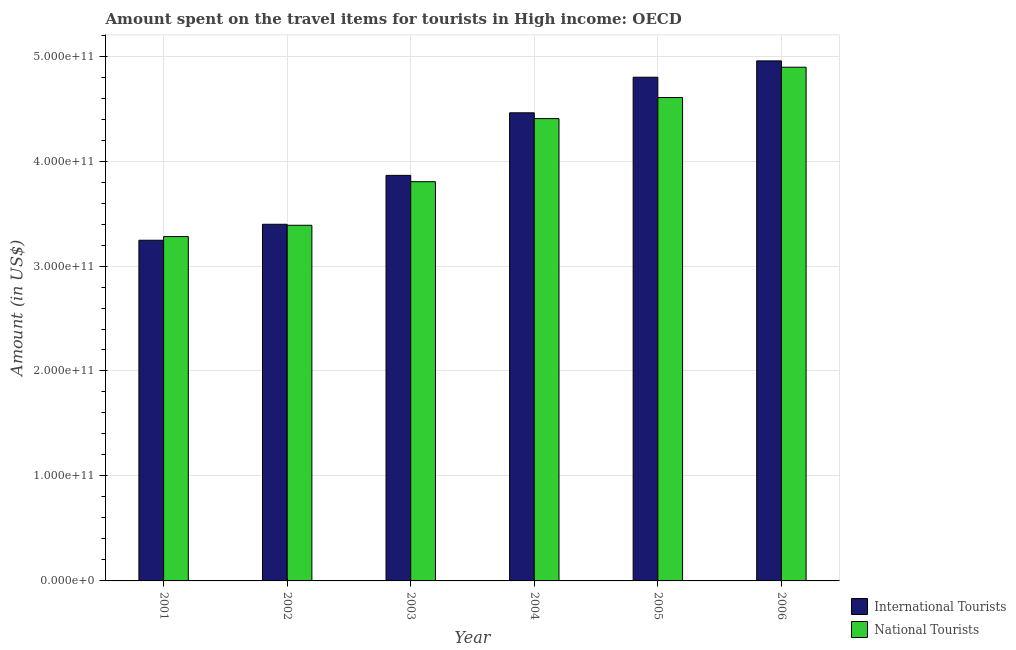Are the number of bars on each tick of the X-axis equal?
Give a very brief answer. Yes. What is the amount spent on travel items of national tourists in 2003?
Your response must be concise. 3.80e+11. Across all years, what is the maximum amount spent on travel items of national tourists?
Ensure brevity in your answer.  4.89e+11. Across all years, what is the minimum amount spent on travel items of national tourists?
Make the answer very short. 3.28e+11. In which year was the amount spent on travel items of national tourists minimum?
Your answer should be very brief. 2001. What is the total amount spent on travel items of national tourists in the graph?
Make the answer very short. 2.44e+12. What is the difference between the amount spent on travel items of national tourists in 2002 and that in 2005?
Your response must be concise. -1.22e+11. What is the difference between the amount spent on travel items of international tourists in 2005 and the amount spent on travel items of national tourists in 2006?
Make the answer very short. -1.56e+1. What is the average amount spent on travel items of international tourists per year?
Provide a succinct answer. 4.12e+11. In the year 2002, what is the difference between the amount spent on travel items of national tourists and amount spent on travel items of international tourists?
Offer a terse response. 0. What is the ratio of the amount spent on travel items of international tourists in 2004 to that in 2005?
Give a very brief answer. 0.93. Is the amount spent on travel items of international tourists in 2005 less than that in 2006?
Your answer should be compact. Yes. What is the difference between the highest and the second highest amount spent on travel items of national tourists?
Your response must be concise. 2.89e+1. What is the difference between the highest and the lowest amount spent on travel items of international tourists?
Your answer should be compact. 1.71e+11. What does the 2nd bar from the left in 2005 represents?
Provide a short and direct response. National Tourists. What does the 1st bar from the right in 2003 represents?
Your response must be concise. National Tourists. Are all the bars in the graph horizontal?
Provide a short and direct response. No. What is the difference between two consecutive major ticks on the Y-axis?
Provide a succinct answer. 1.00e+11. Are the values on the major ticks of Y-axis written in scientific E-notation?
Your answer should be very brief. Yes. Does the graph contain any zero values?
Provide a succinct answer. No. How are the legend labels stacked?
Keep it short and to the point. Vertical. What is the title of the graph?
Offer a terse response. Amount spent on the travel items for tourists in High income: OECD. What is the label or title of the X-axis?
Your answer should be very brief. Year. What is the label or title of the Y-axis?
Your answer should be compact. Amount (in US$). What is the Amount (in US$) in International Tourists in 2001?
Make the answer very short. 3.25e+11. What is the Amount (in US$) of National Tourists in 2001?
Your answer should be compact. 3.28e+11. What is the Amount (in US$) of International Tourists in 2002?
Offer a very short reply. 3.40e+11. What is the Amount (in US$) in National Tourists in 2002?
Give a very brief answer. 3.39e+11. What is the Amount (in US$) of International Tourists in 2003?
Give a very brief answer. 3.86e+11. What is the Amount (in US$) of National Tourists in 2003?
Make the answer very short. 3.80e+11. What is the Amount (in US$) of International Tourists in 2004?
Keep it short and to the point. 4.46e+11. What is the Amount (in US$) in National Tourists in 2004?
Offer a very short reply. 4.40e+11. What is the Amount (in US$) of International Tourists in 2005?
Your answer should be compact. 4.80e+11. What is the Amount (in US$) of National Tourists in 2005?
Your answer should be very brief. 4.61e+11. What is the Amount (in US$) of International Tourists in 2006?
Your response must be concise. 4.95e+11. What is the Amount (in US$) of National Tourists in 2006?
Provide a succinct answer. 4.89e+11. Across all years, what is the maximum Amount (in US$) of International Tourists?
Keep it short and to the point. 4.95e+11. Across all years, what is the maximum Amount (in US$) in National Tourists?
Your response must be concise. 4.89e+11. Across all years, what is the minimum Amount (in US$) of International Tourists?
Keep it short and to the point. 3.25e+11. Across all years, what is the minimum Amount (in US$) of National Tourists?
Provide a short and direct response. 3.28e+11. What is the total Amount (in US$) in International Tourists in the graph?
Provide a succinct answer. 2.47e+12. What is the total Amount (in US$) in National Tourists in the graph?
Give a very brief answer. 2.44e+12. What is the difference between the Amount (in US$) of International Tourists in 2001 and that in 2002?
Keep it short and to the point. -1.52e+1. What is the difference between the Amount (in US$) of National Tourists in 2001 and that in 2002?
Give a very brief answer. -1.08e+1. What is the difference between the Amount (in US$) of International Tourists in 2001 and that in 2003?
Provide a succinct answer. -6.18e+1. What is the difference between the Amount (in US$) in National Tourists in 2001 and that in 2003?
Provide a short and direct response. -5.23e+1. What is the difference between the Amount (in US$) in International Tourists in 2001 and that in 2004?
Keep it short and to the point. -1.21e+11. What is the difference between the Amount (in US$) in National Tourists in 2001 and that in 2004?
Provide a succinct answer. -1.12e+11. What is the difference between the Amount (in US$) of International Tourists in 2001 and that in 2005?
Offer a very short reply. -1.55e+11. What is the difference between the Amount (in US$) in National Tourists in 2001 and that in 2005?
Keep it short and to the point. -1.32e+11. What is the difference between the Amount (in US$) of International Tourists in 2001 and that in 2006?
Provide a succinct answer. -1.71e+11. What is the difference between the Amount (in US$) of National Tourists in 2001 and that in 2006?
Your answer should be compact. -1.61e+11. What is the difference between the Amount (in US$) in International Tourists in 2002 and that in 2003?
Your response must be concise. -4.66e+1. What is the difference between the Amount (in US$) of National Tourists in 2002 and that in 2003?
Make the answer very short. -4.15e+1. What is the difference between the Amount (in US$) in International Tourists in 2002 and that in 2004?
Ensure brevity in your answer.  -1.06e+11. What is the difference between the Amount (in US$) of National Tourists in 2002 and that in 2004?
Your response must be concise. -1.02e+11. What is the difference between the Amount (in US$) of International Tourists in 2002 and that in 2005?
Ensure brevity in your answer.  -1.40e+11. What is the difference between the Amount (in US$) of National Tourists in 2002 and that in 2005?
Your response must be concise. -1.22e+11. What is the difference between the Amount (in US$) of International Tourists in 2002 and that in 2006?
Keep it short and to the point. -1.56e+11. What is the difference between the Amount (in US$) of National Tourists in 2002 and that in 2006?
Give a very brief answer. -1.51e+11. What is the difference between the Amount (in US$) of International Tourists in 2003 and that in 2004?
Provide a succinct answer. -5.96e+1. What is the difference between the Amount (in US$) in National Tourists in 2003 and that in 2004?
Give a very brief answer. -6.01e+1. What is the difference between the Amount (in US$) in International Tourists in 2003 and that in 2005?
Your answer should be compact. -9.35e+1. What is the difference between the Amount (in US$) of National Tourists in 2003 and that in 2005?
Offer a terse response. -8.02e+1. What is the difference between the Amount (in US$) of International Tourists in 2003 and that in 2006?
Offer a terse response. -1.09e+11. What is the difference between the Amount (in US$) in National Tourists in 2003 and that in 2006?
Your answer should be very brief. -1.09e+11. What is the difference between the Amount (in US$) in International Tourists in 2004 and that in 2005?
Provide a succinct answer. -3.39e+1. What is the difference between the Amount (in US$) of National Tourists in 2004 and that in 2005?
Your answer should be compact. -2.01e+1. What is the difference between the Amount (in US$) of International Tourists in 2004 and that in 2006?
Make the answer very short. -4.95e+1. What is the difference between the Amount (in US$) in National Tourists in 2004 and that in 2006?
Offer a very short reply. -4.90e+1. What is the difference between the Amount (in US$) in International Tourists in 2005 and that in 2006?
Offer a terse response. -1.56e+1. What is the difference between the Amount (in US$) in National Tourists in 2005 and that in 2006?
Ensure brevity in your answer.  -2.89e+1. What is the difference between the Amount (in US$) of International Tourists in 2001 and the Amount (in US$) of National Tourists in 2002?
Make the answer very short. -1.43e+1. What is the difference between the Amount (in US$) in International Tourists in 2001 and the Amount (in US$) in National Tourists in 2003?
Give a very brief answer. -5.58e+1. What is the difference between the Amount (in US$) in International Tourists in 2001 and the Amount (in US$) in National Tourists in 2004?
Offer a very short reply. -1.16e+11. What is the difference between the Amount (in US$) in International Tourists in 2001 and the Amount (in US$) in National Tourists in 2005?
Give a very brief answer. -1.36e+11. What is the difference between the Amount (in US$) in International Tourists in 2001 and the Amount (in US$) in National Tourists in 2006?
Your answer should be compact. -1.65e+11. What is the difference between the Amount (in US$) of International Tourists in 2002 and the Amount (in US$) of National Tourists in 2003?
Ensure brevity in your answer.  -4.06e+1. What is the difference between the Amount (in US$) in International Tourists in 2002 and the Amount (in US$) in National Tourists in 2004?
Your answer should be very brief. -1.01e+11. What is the difference between the Amount (in US$) in International Tourists in 2002 and the Amount (in US$) in National Tourists in 2005?
Offer a terse response. -1.21e+11. What is the difference between the Amount (in US$) in International Tourists in 2002 and the Amount (in US$) in National Tourists in 2006?
Your answer should be very brief. -1.50e+11. What is the difference between the Amount (in US$) in International Tourists in 2003 and the Amount (in US$) in National Tourists in 2004?
Your answer should be compact. -5.41e+1. What is the difference between the Amount (in US$) in International Tourists in 2003 and the Amount (in US$) in National Tourists in 2005?
Your answer should be very brief. -7.42e+1. What is the difference between the Amount (in US$) of International Tourists in 2003 and the Amount (in US$) of National Tourists in 2006?
Keep it short and to the point. -1.03e+11. What is the difference between the Amount (in US$) of International Tourists in 2004 and the Amount (in US$) of National Tourists in 2005?
Your answer should be compact. -1.46e+1. What is the difference between the Amount (in US$) in International Tourists in 2004 and the Amount (in US$) in National Tourists in 2006?
Give a very brief answer. -4.34e+1. What is the difference between the Amount (in US$) of International Tourists in 2005 and the Amount (in US$) of National Tourists in 2006?
Give a very brief answer. -9.54e+09. What is the average Amount (in US$) in International Tourists per year?
Give a very brief answer. 4.12e+11. What is the average Amount (in US$) of National Tourists per year?
Give a very brief answer. 4.06e+11. In the year 2001, what is the difference between the Amount (in US$) of International Tourists and Amount (in US$) of National Tourists?
Your answer should be compact. -3.49e+09. In the year 2002, what is the difference between the Amount (in US$) in International Tourists and Amount (in US$) in National Tourists?
Give a very brief answer. 9.43e+08. In the year 2003, what is the difference between the Amount (in US$) in International Tourists and Amount (in US$) in National Tourists?
Give a very brief answer. 6.00e+09. In the year 2004, what is the difference between the Amount (in US$) in International Tourists and Amount (in US$) in National Tourists?
Make the answer very short. 5.52e+09. In the year 2005, what is the difference between the Amount (in US$) of International Tourists and Amount (in US$) of National Tourists?
Your answer should be very brief. 1.93e+1. In the year 2006, what is the difference between the Amount (in US$) of International Tourists and Amount (in US$) of National Tourists?
Offer a terse response. 6.04e+09. What is the ratio of the Amount (in US$) of International Tourists in 2001 to that in 2002?
Your answer should be compact. 0.96. What is the ratio of the Amount (in US$) in National Tourists in 2001 to that in 2002?
Your answer should be very brief. 0.97. What is the ratio of the Amount (in US$) of International Tourists in 2001 to that in 2003?
Keep it short and to the point. 0.84. What is the ratio of the Amount (in US$) of National Tourists in 2001 to that in 2003?
Offer a terse response. 0.86. What is the ratio of the Amount (in US$) of International Tourists in 2001 to that in 2004?
Your answer should be compact. 0.73. What is the ratio of the Amount (in US$) in National Tourists in 2001 to that in 2004?
Provide a succinct answer. 0.74. What is the ratio of the Amount (in US$) of International Tourists in 2001 to that in 2005?
Your answer should be compact. 0.68. What is the ratio of the Amount (in US$) in National Tourists in 2001 to that in 2005?
Your response must be concise. 0.71. What is the ratio of the Amount (in US$) in International Tourists in 2001 to that in 2006?
Your answer should be compact. 0.66. What is the ratio of the Amount (in US$) in National Tourists in 2001 to that in 2006?
Ensure brevity in your answer.  0.67. What is the ratio of the Amount (in US$) in International Tourists in 2002 to that in 2003?
Your answer should be very brief. 0.88. What is the ratio of the Amount (in US$) of National Tourists in 2002 to that in 2003?
Provide a succinct answer. 0.89. What is the ratio of the Amount (in US$) in International Tourists in 2002 to that in 2004?
Provide a short and direct response. 0.76. What is the ratio of the Amount (in US$) of National Tourists in 2002 to that in 2004?
Make the answer very short. 0.77. What is the ratio of the Amount (in US$) of International Tourists in 2002 to that in 2005?
Give a very brief answer. 0.71. What is the ratio of the Amount (in US$) in National Tourists in 2002 to that in 2005?
Your answer should be compact. 0.74. What is the ratio of the Amount (in US$) of International Tourists in 2002 to that in 2006?
Keep it short and to the point. 0.69. What is the ratio of the Amount (in US$) of National Tourists in 2002 to that in 2006?
Ensure brevity in your answer.  0.69. What is the ratio of the Amount (in US$) in International Tourists in 2003 to that in 2004?
Make the answer very short. 0.87. What is the ratio of the Amount (in US$) in National Tourists in 2003 to that in 2004?
Keep it short and to the point. 0.86. What is the ratio of the Amount (in US$) of International Tourists in 2003 to that in 2005?
Give a very brief answer. 0.81. What is the ratio of the Amount (in US$) of National Tourists in 2003 to that in 2005?
Your answer should be compact. 0.83. What is the ratio of the Amount (in US$) of International Tourists in 2003 to that in 2006?
Your answer should be very brief. 0.78. What is the ratio of the Amount (in US$) in National Tourists in 2003 to that in 2006?
Your response must be concise. 0.78. What is the ratio of the Amount (in US$) of International Tourists in 2004 to that in 2005?
Your answer should be very brief. 0.93. What is the ratio of the Amount (in US$) in National Tourists in 2004 to that in 2005?
Offer a terse response. 0.96. What is the ratio of the Amount (in US$) in International Tourists in 2004 to that in 2006?
Give a very brief answer. 0.9. What is the ratio of the Amount (in US$) of National Tourists in 2004 to that in 2006?
Keep it short and to the point. 0.9. What is the ratio of the Amount (in US$) of International Tourists in 2005 to that in 2006?
Provide a succinct answer. 0.97. What is the ratio of the Amount (in US$) in National Tourists in 2005 to that in 2006?
Provide a short and direct response. 0.94. What is the difference between the highest and the second highest Amount (in US$) in International Tourists?
Your answer should be very brief. 1.56e+1. What is the difference between the highest and the second highest Amount (in US$) of National Tourists?
Offer a very short reply. 2.89e+1. What is the difference between the highest and the lowest Amount (in US$) in International Tourists?
Offer a very short reply. 1.71e+11. What is the difference between the highest and the lowest Amount (in US$) in National Tourists?
Offer a very short reply. 1.61e+11. 